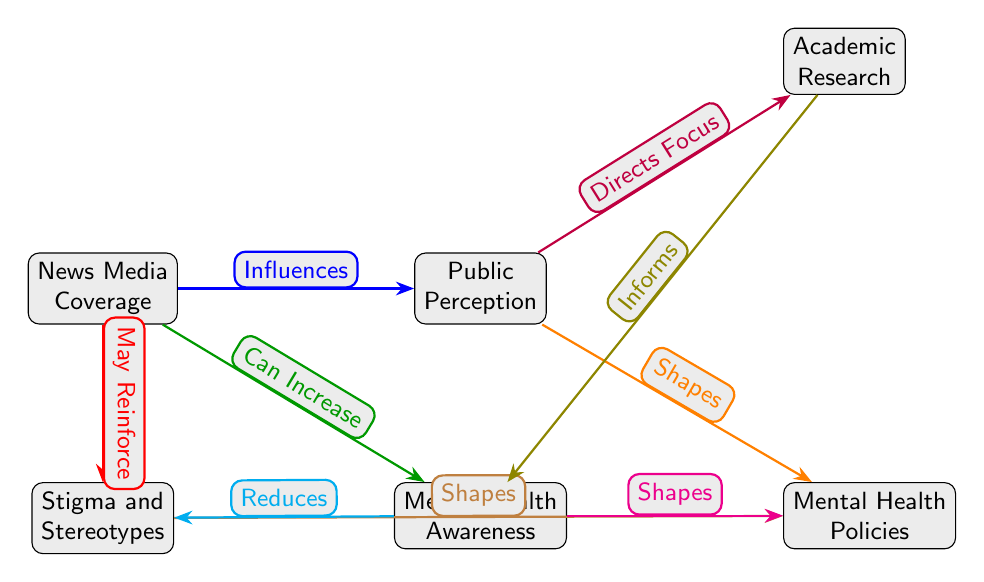What is the top left node in the diagram? The top left node in the diagram is labeled "News Media Coverage." This can be identified by locating the first node on the upper left side of the diagram layout.
Answer: News Media Coverage How many nodes are present in the diagram? By counting each of the distinct elements represented in the diagram, we find there are a total of six nodes: News Media Coverage, Public Perception, Stigma and Stereotypes, Mental Health Awareness, Mental Health Policies, and Academic Research.
Answer: 6 What does the "News Media Coverage" influence? The "News Media Coverage" influences the "Public Perception," as indicated by the blue arrow labeled "Influences." This is a direct flow from the News Media to Public Perception.
Answer: Public Perception Which node directly connects to both "Public Perception" and "Stigma and Stereotypes"? The node "Mental Health Policies" directly connects to both "Public Perception" and "Stigma and Stereotypes." This can be observed by tracing the edges that stem from either of those two nodes towards "Mental Health Policies."
Answer: Mental Health Policies What relationship exists between "Mental Health Awareness" and "Stigma and Stereotypes"? The relationship is that "Mental Health Awareness" reduces "Stigma and Stereotypes," as shown by the cyan arrow labeled "Reduces." This indicates an impact where increased awareness can lead to lesser stigma.
Answer: Reduces How does "Public Perception" shape "Mental Health Policies"? "Public Perception" shapes "Mental Health Policies" as reflected by the orange arrow labeled "Shapes," indicating a directional influence from Public Perception to policies regarding mental health issues.
Answer: Shapes What role does "Academic Research" play in the context of "Mental Health Awareness"? "Academic Research" informs "Mental Health Awareness," as indicated by the olive arrow labeled "Informs," showing that research contributes knowledge that increases awareness about mental health.
Answer: Informs Which node is associated with the possibility of reinforcing stigma in the media coverage context? The node associated with the possibility of reinforcing stigma is "Stigma and Stereotypes," as indicated by the red arrow labeled "May Reinforce," which connects back from News Media Coverage to this node.
Answer: Stigma and Stereotypes 